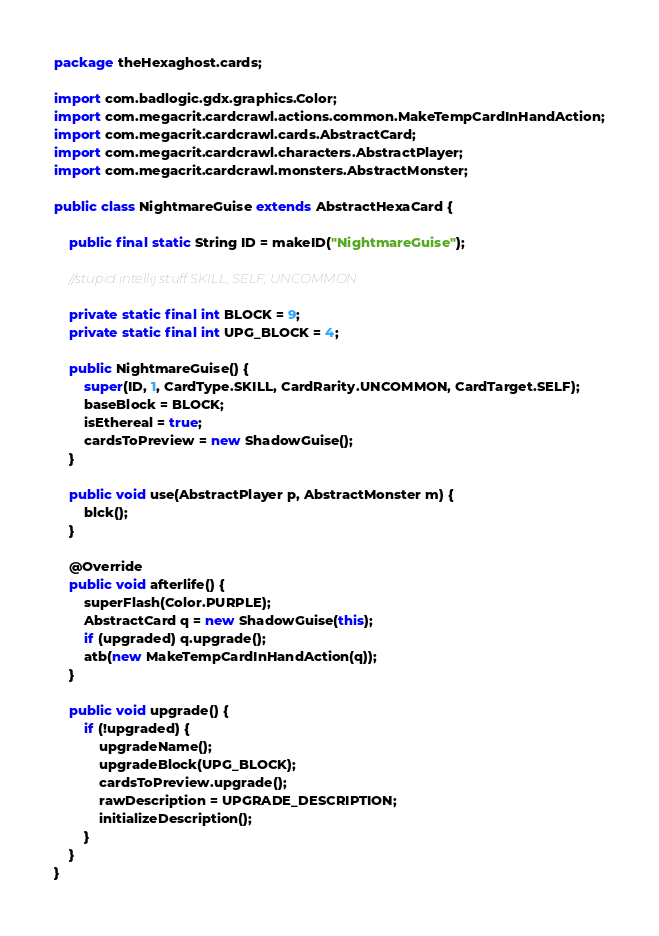<code> <loc_0><loc_0><loc_500><loc_500><_Java_>package theHexaghost.cards;

import com.badlogic.gdx.graphics.Color;
import com.megacrit.cardcrawl.actions.common.MakeTempCardInHandAction;
import com.megacrit.cardcrawl.cards.AbstractCard;
import com.megacrit.cardcrawl.characters.AbstractPlayer;
import com.megacrit.cardcrawl.monsters.AbstractMonster;

public class NightmareGuise extends AbstractHexaCard {

    public final static String ID = makeID("NightmareGuise");

    //stupid intellij stuff SKILL, SELF, UNCOMMON

    private static final int BLOCK = 9;
    private static final int UPG_BLOCK = 4;

    public NightmareGuise() {
        super(ID, 1, CardType.SKILL, CardRarity.UNCOMMON, CardTarget.SELF);
        baseBlock = BLOCK;
        isEthereal = true;
        cardsToPreview = new ShadowGuise();
    }

    public void use(AbstractPlayer p, AbstractMonster m) {
        blck();
    }

    @Override
    public void afterlife() {
        superFlash(Color.PURPLE);
        AbstractCard q = new ShadowGuise(this);
        if (upgraded) q.upgrade();
        atb(new MakeTempCardInHandAction(q));
    }

    public void upgrade() {
        if (!upgraded) {
            upgradeName();
            upgradeBlock(UPG_BLOCK);
            cardsToPreview.upgrade();
            rawDescription = UPGRADE_DESCRIPTION;
            initializeDescription();
        }
    }
}</code> 